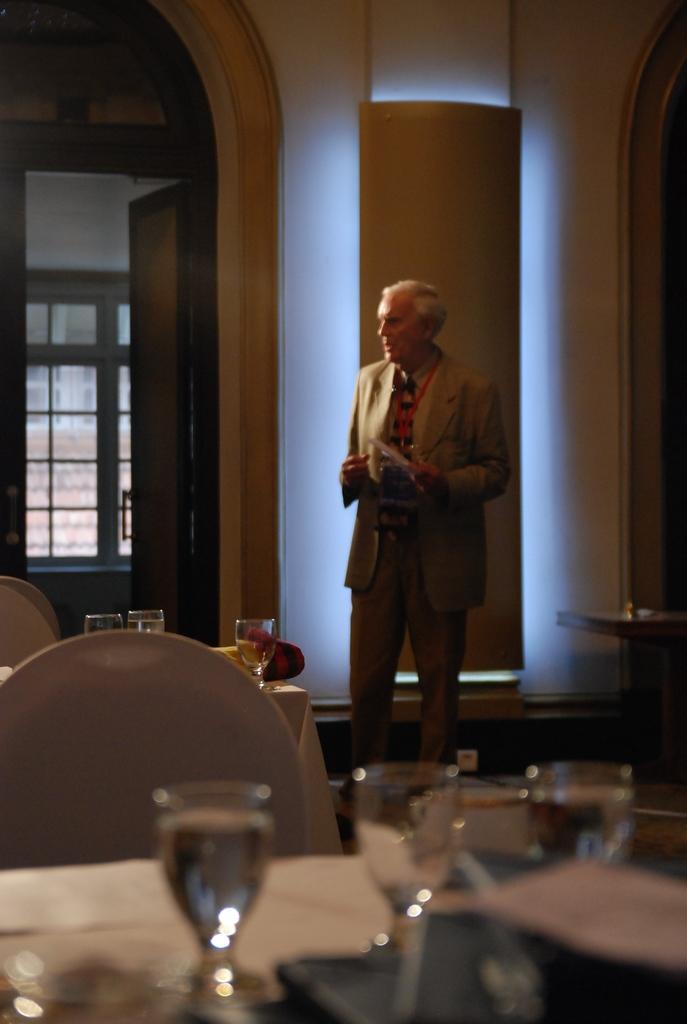In one or two sentences, can you explain what this image depicts? In this picture there is a man standing. In front of him there are some tables and chairs. On the table there are some glasses here. In the background there is a door and a wall here. 